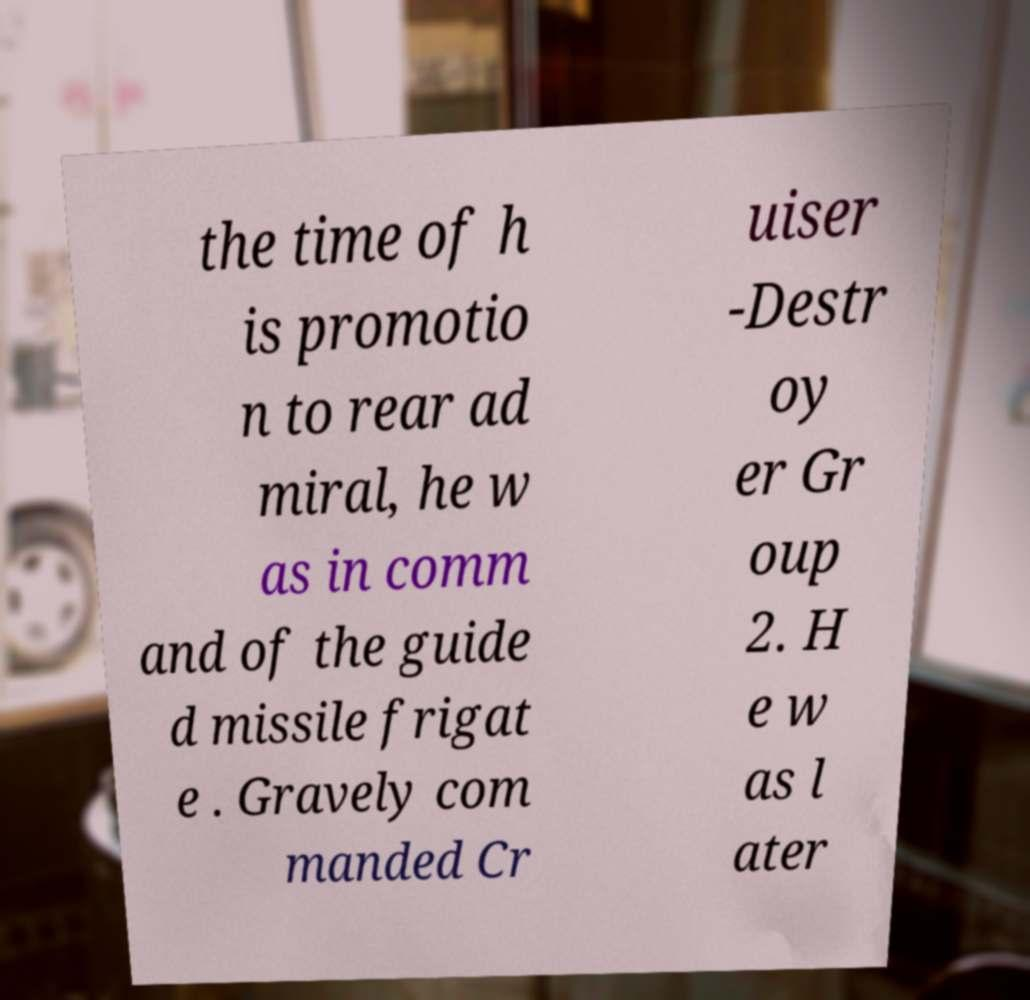Please read and relay the text visible in this image. What does it say? the time of h is promotio n to rear ad miral, he w as in comm and of the guide d missile frigat e . Gravely com manded Cr uiser -Destr oy er Gr oup 2. H e w as l ater 